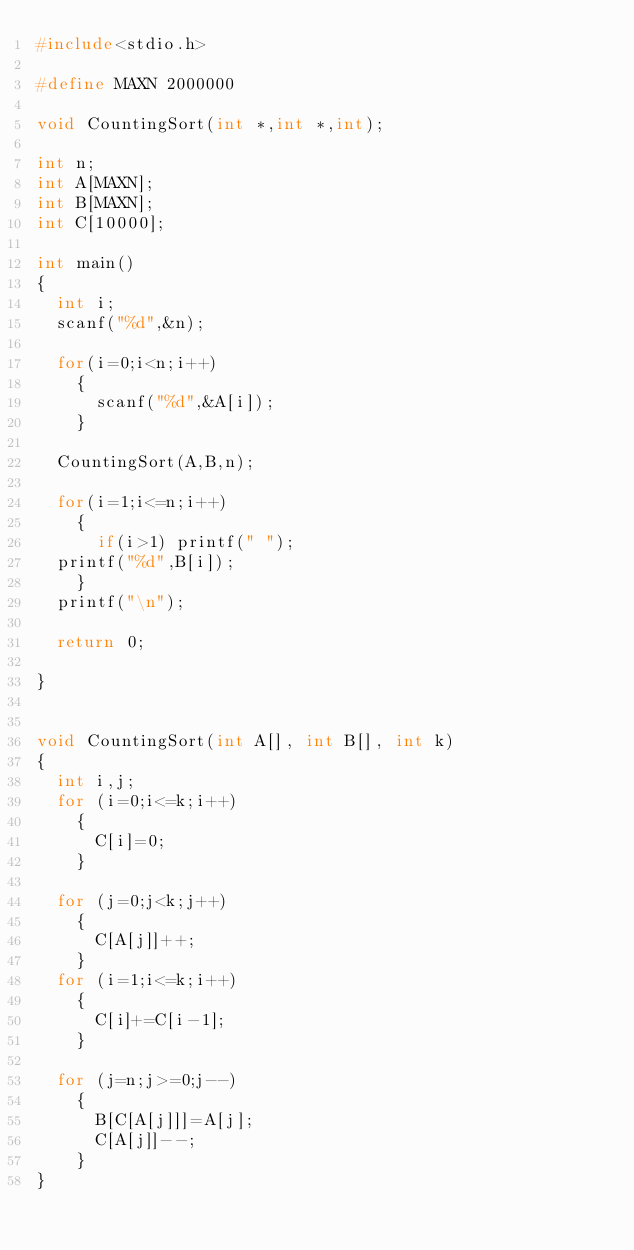<code> <loc_0><loc_0><loc_500><loc_500><_C_>#include<stdio.h>

#define MAXN 2000000

void CountingSort(int *,int *,int);

int n;
int A[MAXN];
int B[MAXN];
int C[10000];

int main()
{
  int i;
  scanf("%d",&n);

  for(i=0;i<n;i++)
    {
      scanf("%d",&A[i]);
    }
  
  CountingSort(A,B,n);

  for(i=1;i<=n;i++)
    {
      if(i>1) printf(" ");
  printf("%d",B[i]);
    }
  printf("\n");
  
  return 0;

}


void CountingSort(int A[], int B[], int k)
{
  int i,j;
  for (i=0;i<=k;i++)
    {
      C[i]=0;
    }

  for (j=0;j<k;j++)
    {
      C[A[j]]++;
    }
  for (i=1;i<=k;i++)
    {
      C[i]+=C[i-1];
    }
  
  for (j=n;j>=0;j--)
    {
      B[C[A[j]]]=A[j];
      C[A[j]]--;
    }
}</code> 